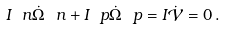Convert formula to latex. <formula><loc_0><loc_0><loc_500><loc_500>I _ { \ } n \dot { \Omega } _ { \ } n + I _ { \ } p \dot { \Omega } _ { \ } p = I \dot { \mathcal { V } } = 0 \, .</formula> 